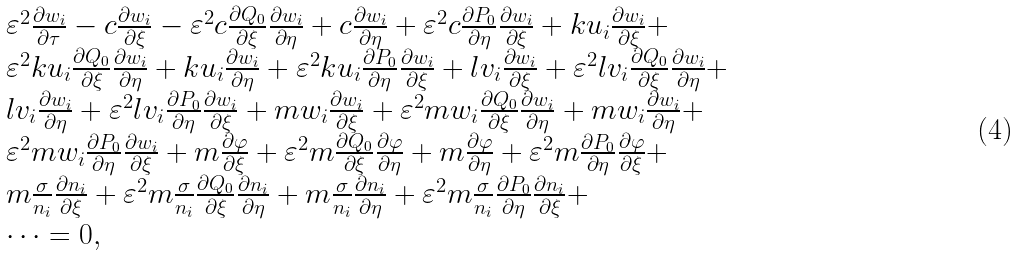Convert formula to latex. <formula><loc_0><loc_0><loc_500><loc_500>\begin{array} { l } { \varepsilon ^ { 2 } } \frac { { \partial { w _ { i } } } } { \partial \tau } - c \frac { { \partial { w _ { i } } } } { \partial \xi } - { \varepsilon ^ { 2 } } c \frac { { \partial { Q _ { 0 } } } } { \partial \xi } \frac { { \partial { w _ { i } } } } { \partial \eta } + c \frac { { \partial { w _ { i } } } } { \partial \eta } + { \varepsilon ^ { 2 } } c \frac { { \partial { P _ { 0 } } } } { \partial \eta } \frac { { \partial { w _ { i } } } } { \partial \xi } + k { u _ { i } } \frac { { \partial { w _ { i } } } } { \partial \xi } + \\ { \varepsilon ^ { 2 } } k { u _ { i } } \frac { { \partial { Q _ { 0 } } } } { \partial \xi } \frac { { \partial { w _ { i } } } } { \partial \eta } + k { u _ { i } } \frac { { \partial { w _ { i } } } } { \partial \eta } + { \varepsilon ^ { 2 } } k { u _ { i } } \frac { { \partial { P _ { 0 } } } } { \partial \eta } \frac { { \partial { w _ { i } } } } { \partial \xi } + l { v _ { i } } \frac { { \partial { w _ { i } } } } { \partial \xi } + { \varepsilon ^ { 2 } } l { v _ { i } } \frac { { \partial { Q _ { 0 } } } } { \partial \xi } \frac { { \partial { w _ { i } } } } { \partial \eta } + \\ l { v _ { i } } \frac { { \partial { w _ { i } } } } { \partial \eta } + { \varepsilon ^ { 2 } } l { v _ { i } } \frac { { \partial { P _ { 0 } } } } { \partial \eta } \frac { { \partial { w _ { i } } } } { \partial \xi } + m { w _ { i } } \frac { { \partial { w _ { i } } } } { \partial \xi } + { \varepsilon ^ { 2 } } m { w _ { i } } \frac { { \partial { Q _ { 0 } } } } { \partial \xi } \frac { { \partial { w _ { i } } } } { \partial \eta } + m { w _ { i } } \frac { { \partial { w _ { i } } } } { \partial \eta } + \\ { \varepsilon ^ { 2 } } m { w _ { i } } \frac { { \partial { P _ { 0 } } } } { \partial \eta } \frac { { \partial { w _ { i } } } } { \partial \xi } + m \frac { \partial \varphi } { \partial \xi } + { \varepsilon ^ { 2 } } m \frac { { \partial { Q _ { 0 } } } } { \partial \xi } \frac { \partial \varphi } { \partial \eta } + m \frac { \partial \varphi } { \partial \eta } + { \varepsilon ^ { 2 } } m \frac { { \partial { P _ { 0 } } } } { \partial \eta } \frac { \partial \varphi } { \partial \xi } + \\ m \frac { \sigma } { n _ { i } } \frac { { \partial { n _ { i } } } } { \partial \xi } + { \varepsilon ^ { 2 } } m \frac { \sigma } { n _ { i } } \frac { { \partial { Q _ { 0 } } } } { \partial \xi } \frac { { \partial { n _ { i } } } } { \partial \eta } + m \frac { \sigma } { n _ { i } } \frac { { \partial { n _ { i } } } } { \partial \eta } + { \varepsilon ^ { 2 } } m \frac { \sigma } { n _ { i } } \frac { { \partial { P _ { 0 } } } } { \partial \eta } \frac { { \partial { n _ { i } } } } { \partial \xi } + \\ \dots = 0 , \\ \end{array}</formula> 